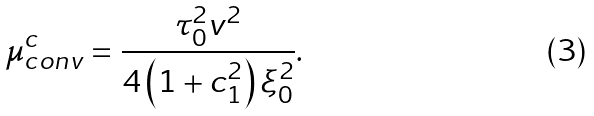Convert formula to latex. <formula><loc_0><loc_0><loc_500><loc_500>\mu ^ { c } _ { c o n v } = \frac { \tau ^ { 2 } _ { 0 } v ^ { 2 } } { 4 \left ( 1 + c ^ { 2 } _ { 1 } \right ) \xi ^ { 2 } _ { 0 } } .</formula> 